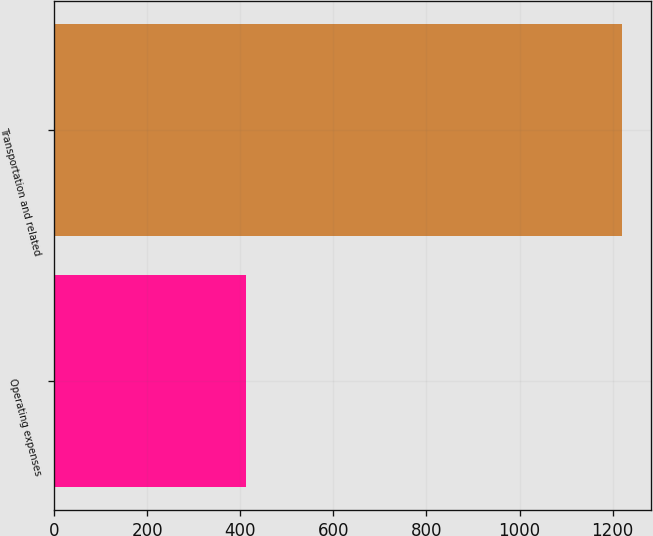Convert chart. <chart><loc_0><loc_0><loc_500><loc_500><bar_chart><fcel>Operating expenses<fcel>Transportation and related<nl><fcel>412<fcel>1221<nl></chart> 